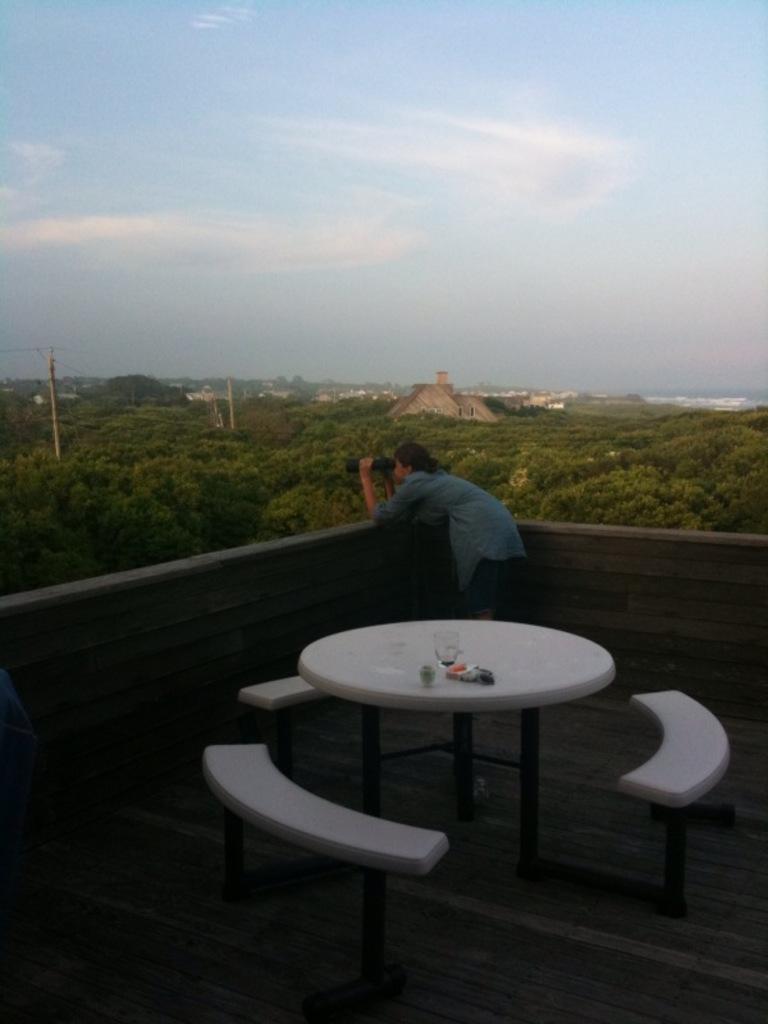Describe this image in one or two sentences. In this image there are stools and a table. On the table there are glasses. Behind the table there is a woman standing. She is holding a binoculars in her hand. In front of her there is a wall. Behind the wall there are trees, buildings and poles. At the top there is the sky. 